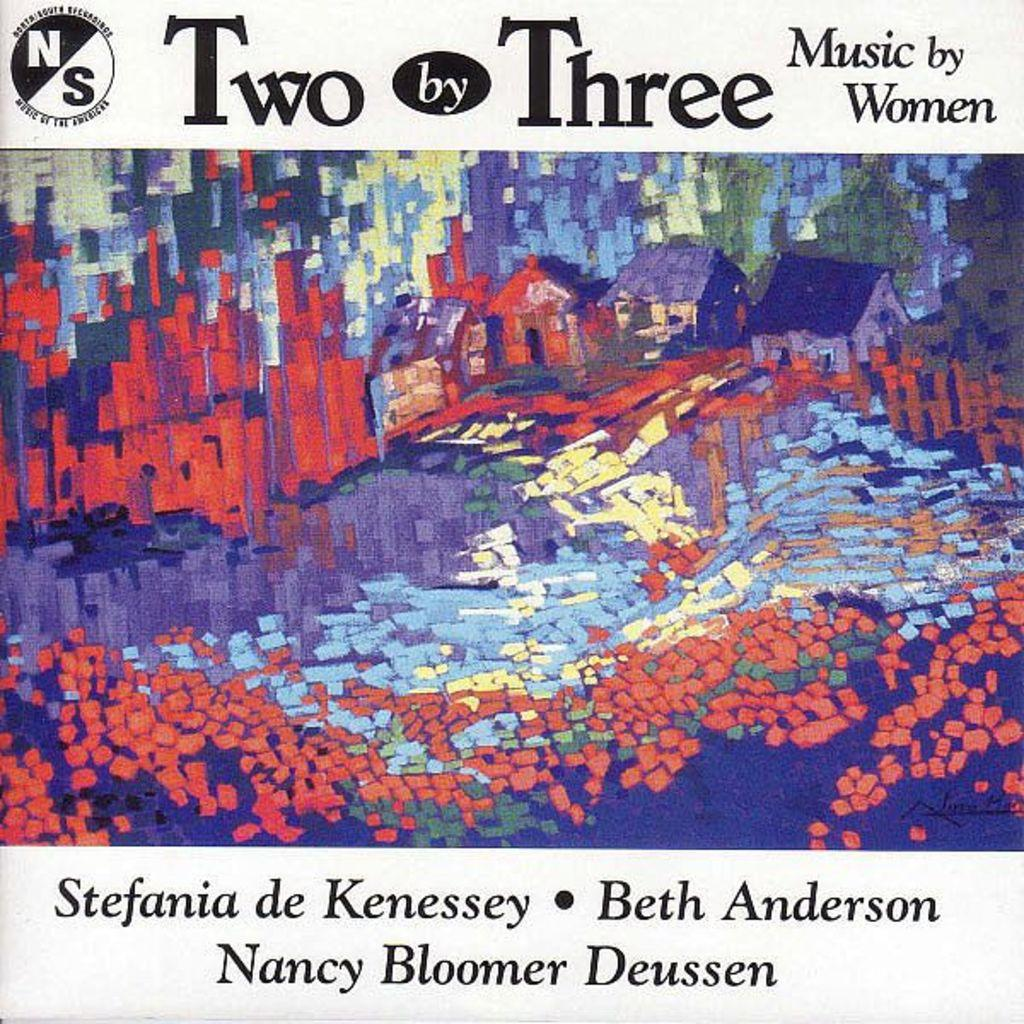<image>
Provide a brief description of the given image. A music cover that says Two by Three Music by Women that has an illustrated village 